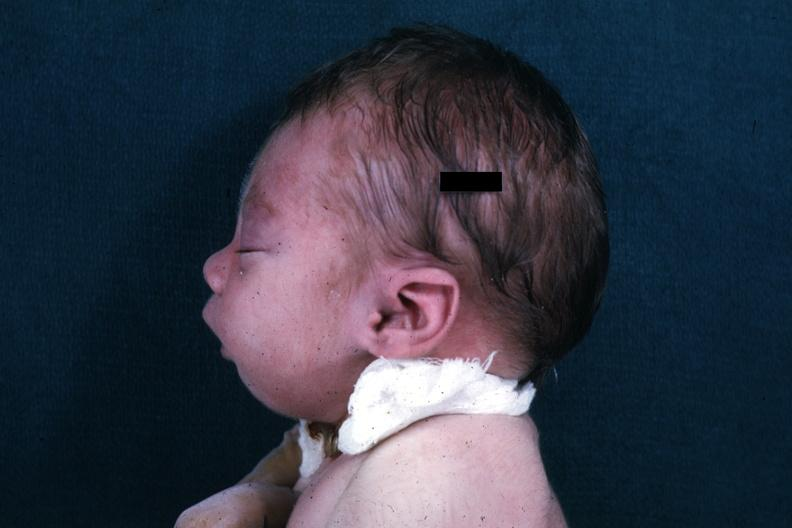s pierre robin sndrome present?
Answer the question using a single word or phrase. Yes 